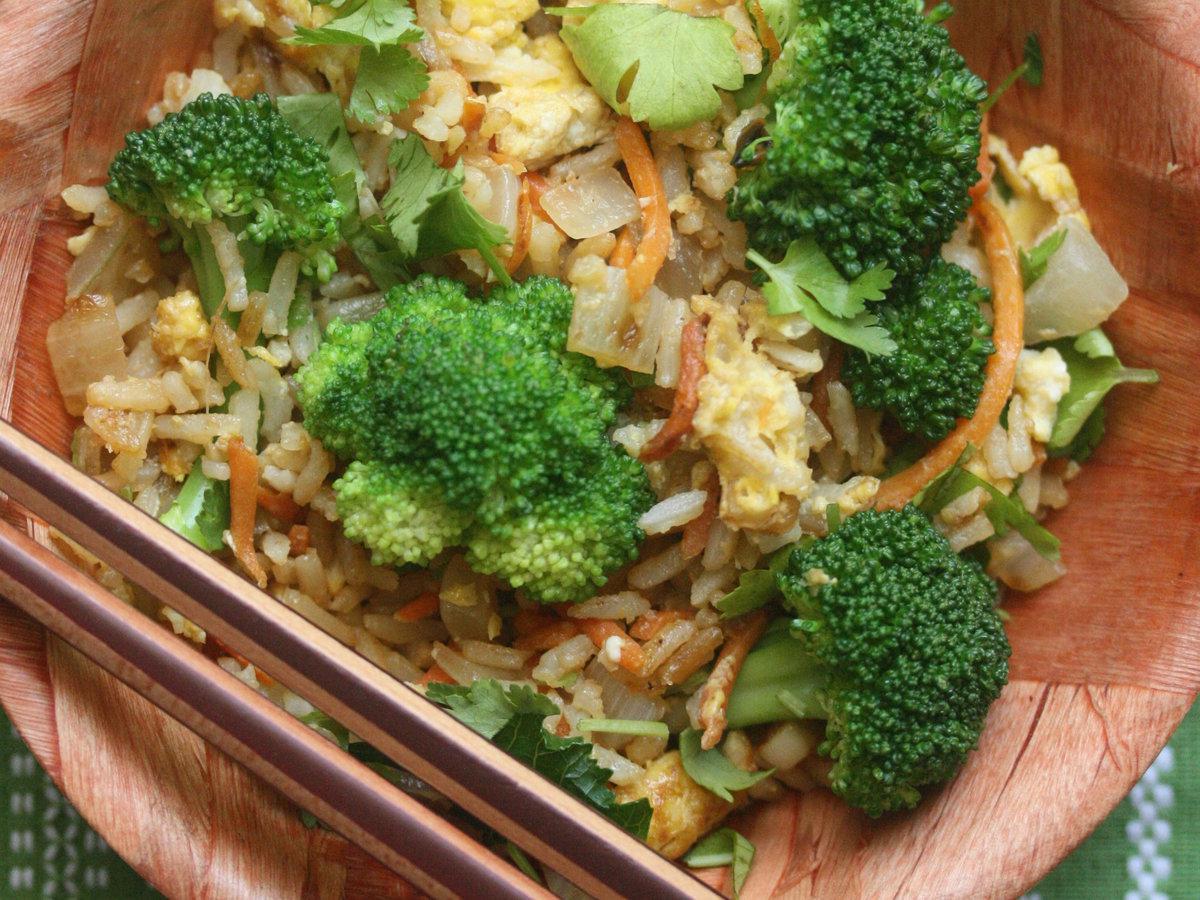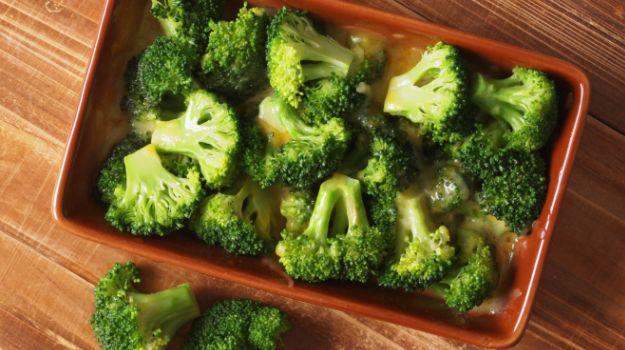The first image is the image on the left, the second image is the image on the right. Considering the images on both sides, is "Two parallel sticks are over a round bowl containing broccoli florets in one image." valid? Answer yes or no. Yes. The first image is the image on the left, the second image is the image on the right. Examine the images to the left and right. Is the description "Everything is in white bowls." accurate? Answer yes or no. No. 